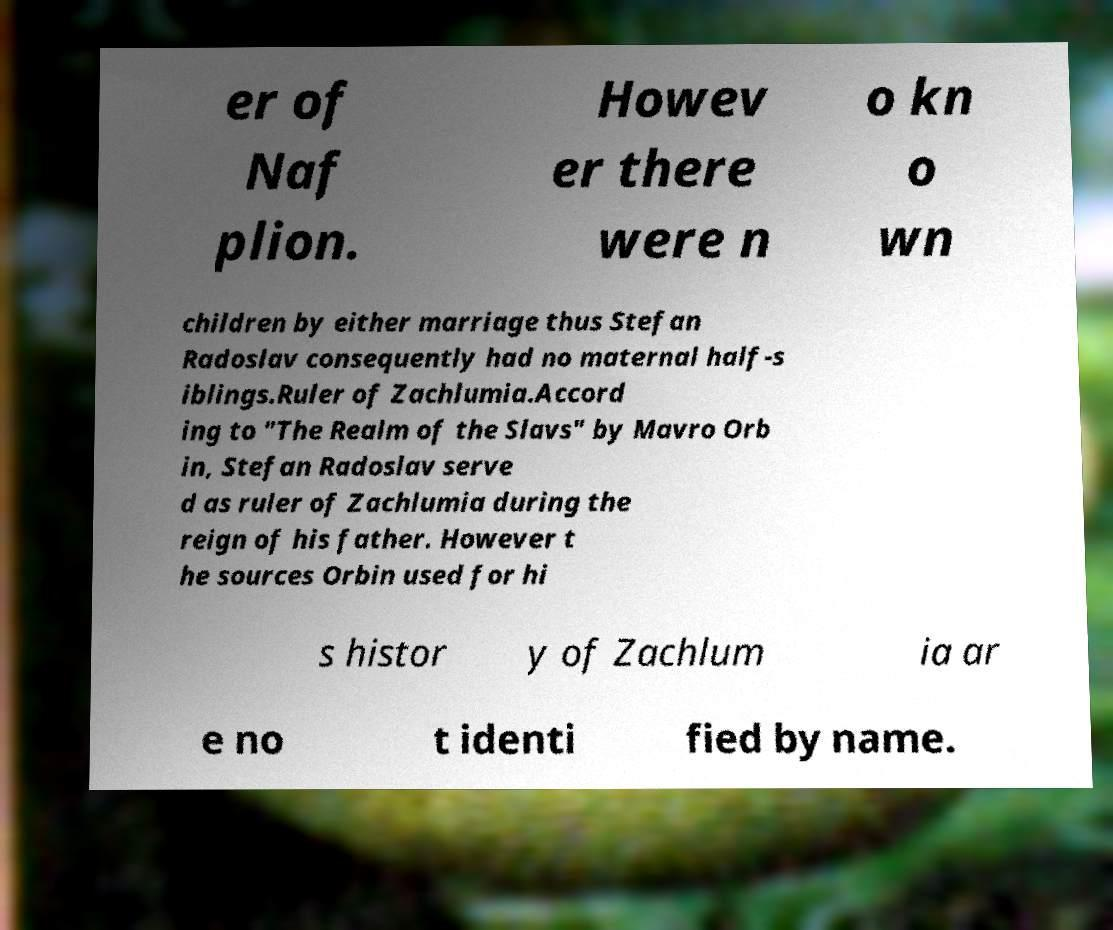Can you accurately transcribe the text from the provided image for me? er of Naf plion. Howev er there were n o kn o wn children by either marriage thus Stefan Radoslav consequently had no maternal half-s iblings.Ruler of Zachlumia.Accord ing to "The Realm of the Slavs" by Mavro Orb in, Stefan Radoslav serve d as ruler of Zachlumia during the reign of his father. However t he sources Orbin used for hi s histor y of Zachlum ia ar e no t identi fied by name. 